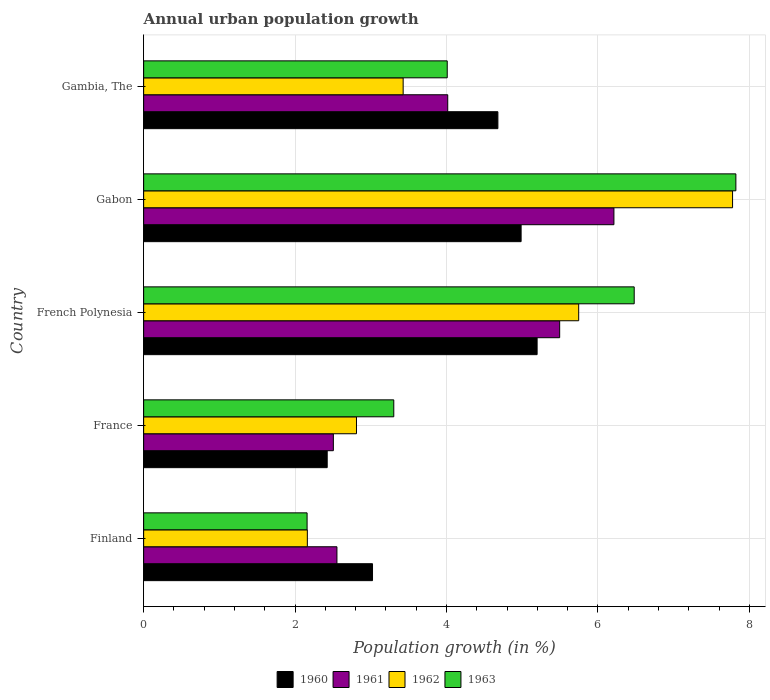Are the number of bars per tick equal to the number of legend labels?
Your response must be concise. Yes. Are the number of bars on each tick of the Y-axis equal?
Ensure brevity in your answer.  Yes. How many bars are there on the 1st tick from the top?
Your response must be concise. 4. How many bars are there on the 2nd tick from the bottom?
Your answer should be compact. 4. What is the label of the 2nd group of bars from the top?
Provide a short and direct response. Gabon. What is the percentage of urban population growth in 1963 in Gabon?
Provide a succinct answer. 7.82. Across all countries, what is the maximum percentage of urban population growth in 1963?
Offer a terse response. 7.82. Across all countries, what is the minimum percentage of urban population growth in 1962?
Ensure brevity in your answer.  2.16. In which country was the percentage of urban population growth in 1962 maximum?
Offer a very short reply. Gabon. In which country was the percentage of urban population growth in 1963 minimum?
Your answer should be compact. Finland. What is the total percentage of urban population growth in 1962 in the graph?
Offer a very short reply. 21.93. What is the difference between the percentage of urban population growth in 1961 in Finland and that in Gabon?
Offer a terse response. -3.66. What is the difference between the percentage of urban population growth in 1960 in France and the percentage of urban population growth in 1963 in Gambia, The?
Offer a terse response. -1.59. What is the average percentage of urban population growth in 1962 per country?
Your answer should be compact. 4.39. What is the difference between the percentage of urban population growth in 1961 and percentage of urban population growth in 1963 in Finland?
Your response must be concise. 0.39. In how many countries, is the percentage of urban population growth in 1963 greater than 5.6 %?
Your response must be concise. 2. What is the ratio of the percentage of urban population growth in 1963 in France to that in Gabon?
Your answer should be very brief. 0.42. What is the difference between the highest and the second highest percentage of urban population growth in 1962?
Provide a succinct answer. 2.03. What is the difference between the highest and the lowest percentage of urban population growth in 1960?
Your response must be concise. 2.77. In how many countries, is the percentage of urban population growth in 1963 greater than the average percentage of urban population growth in 1963 taken over all countries?
Offer a terse response. 2. Is it the case that in every country, the sum of the percentage of urban population growth in 1961 and percentage of urban population growth in 1962 is greater than the sum of percentage of urban population growth in 1960 and percentage of urban population growth in 1963?
Offer a very short reply. No. What does the 1st bar from the top in France represents?
Offer a terse response. 1963. What does the 3rd bar from the bottom in Gambia, The represents?
Your answer should be compact. 1962. Is it the case that in every country, the sum of the percentage of urban population growth in 1960 and percentage of urban population growth in 1961 is greater than the percentage of urban population growth in 1962?
Ensure brevity in your answer.  Yes. How many bars are there?
Make the answer very short. 20. Are all the bars in the graph horizontal?
Offer a very short reply. Yes. What is the difference between two consecutive major ticks on the X-axis?
Provide a short and direct response. 2. Are the values on the major ticks of X-axis written in scientific E-notation?
Provide a short and direct response. No. What is the title of the graph?
Provide a short and direct response. Annual urban population growth. Does "1960" appear as one of the legend labels in the graph?
Ensure brevity in your answer.  Yes. What is the label or title of the X-axis?
Give a very brief answer. Population growth (in %). What is the label or title of the Y-axis?
Ensure brevity in your answer.  Country. What is the Population growth (in %) in 1960 in Finland?
Offer a terse response. 3.02. What is the Population growth (in %) in 1961 in Finland?
Make the answer very short. 2.55. What is the Population growth (in %) in 1962 in Finland?
Offer a very short reply. 2.16. What is the Population growth (in %) of 1963 in Finland?
Provide a succinct answer. 2.16. What is the Population growth (in %) in 1960 in France?
Offer a terse response. 2.42. What is the Population growth (in %) of 1961 in France?
Your response must be concise. 2.51. What is the Population growth (in %) of 1962 in France?
Ensure brevity in your answer.  2.81. What is the Population growth (in %) in 1963 in France?
Your response must be concise. 3.3. What is the Population growth (in %) in 1960 in French Polynesia?
Offer a terse response. 5.2. What is the Population growth (in %) in 1961 in French Polynesia?
Make the answer very short. 5.5. What is the Population growth (in %) of 1962 in French Polynesia?
Provide a succinct answer. 5.75. What is the Population growth (in %) of 1963 in French Polynesia?
Your response must be concise. 6.48. What is the Population growth (in %) in 1960 in Gabon?
Your answer should be compact. 4.99. What is the Population growth (in %) of 1961 in Gabon?
Keep it short and to the point. 6.21. What is the Population growth (in %) in 1962 in Gabon?
Offer a terse response. 7.78. What is the Population growth (in %) of 1963 in Gabon?
Your response must be concise. 7.82. What is the Population growth (in %) of 1960 in Gambia, The?
Provide a short and direct response. 4.68. What is the Population growth (in %) of 1961 in Gambia, The?
Offer a terse response. 4.02. What is the Population growth (in %) of 1962 in Gambia, The?
Offer a very short reply. 3.43. What is the Population growth (in %) of 1963 in Gambia, The?
Provide a succinct answer. 4.01. Across all countries, what is the maximum Population growth (in %) of 1960?
Keep it short and to the point. 5.2. Across all countries, what is the maximum Population growth (in %) in 1961?
Your answer should be very brief. 6.21. Across all countries, what is the maximum Population growth (in %) of 1962?
Provide a succinct answer. 7.78. Across all countries, what is the maximum Population growth (in %) of 1963?
Make the answer very short. 7.82. Across all countries, what is the minimum Population growth (in %) of 1960?
Offer a terse response. 2.42. Across all countries, what is the minimum Population growth (in %) in 1961?
Keep it short and to the point. 2.51. Across all countries, what is the minimum Population growth (in %) in 1962?
Make the answer very short. 2.16. Across all countries, what is the minimum Population growth (in %) of 1963?
Offer a terse response. 2.16. What is the total Population growth (in %) in 1960 in the graph?
Provide a short and direct response. 20.31. What is the total Population growth (in %) in 1961 in the graph?
Your answer should be compact. 20.78. What is the total Population growth (in %) of 1962 in the graph?
Ensure brevity in your answer.  21.93. What is the total Population growth (in %) in 1963 in the graph?
Offer a very short reply. 23.78. What is the difference between the Population growth (in %) in 1960 in Finland and that in France?
Offer a terse response. 0.6. What is the difference between the Population growth (in %) in 1961 in Finland and that in France?
Provide a succinct answer. 0.05. What is the difference between the Population growth (in %) in 1962 in Finland and that in France?
Offer a terse response. -0.65. What is the difference between the Population growth (in %) of 1963 in Finland and that in France?
Offer a very short reply. -1.15. What is the difference between the Population growth (in %) in 1960 in Finland and that in French Polynesia?
Your answer should be very brief. -2.17. What is the difference between the Population growth (in %) of 1961 in Finland and that in French Polynesia?
Keep it short and to the point. -2.94. What is the difference between the Population growth (in %) of 1962 in Finland and that in French Polynesia?
Ensure brevity in your answer.  -3.58. What is the difference between the Population growth (in %) of 1963 in Finland and that in French Polynesia?
Provide a succinct answer. -4.32. What is the difference between the Population growth (in %) of 1960 in Finland and that in Gabon?
Ensure brevity in your answer.  -1.96. What is the difference between the Population growth (in %) in 1961 in Finland and that in Gabon?
Your answer should be very brief. -3.66. What is the difference between the Population growth (in %) in 1962 in Finland and that in Gabon?
Ensure brevity in your answer.  -5.62. What is the difference between the Population growth (in %) of 1963 in Finland and that in Gabon?
Give a very brief answer. -5.66. What is the difference between the Population growth (in %) of 1960 in Finland and that in Gambia, The?
Provide a succinct answer. -1.66. What is the difference between the Population growth (in %) in 1961 in Finland and that in Gambia, The?
Your answer should be very brief. -1.46. What is the difference between the Population growth (in %) of 1962 in Finland and that in Gambia, The?
Give a very brief answer. -1.27. What is the difference between the Population growth (in %) of 1963 in Finland and that in Gambia, The?
Give a very brief answer. -1.85. What is the difference between the Population growth (in %) in 1960 in France and that in French Polynesia?
Provide a short and direct response. -2.77. What is the difference between the Population growth (in %) in 1961 in France and that in French Polynesia?
Your answer should be very brief. -2.99. What is the difference between the Population growth (in %) in 1962 in France and that in French Polynesia?
Make the answer very short. -2.94. What is the difference between the Population growth (in %) in 1963 in France and that in French Polynesia?
Ensure brevity in your answer.  -3.18. What is the difference between the Population growth (in %) in 1960 in France and that in Gabon?
Ensure brevity in your answer.  -2.56. What is the difference between the Population growth (in %) in 1961 in France and that in Gabon?
Give a very brief answer. -3.71. What is the difference between the Population growth (in %) of 1962 in France and that in Gabon?
Provide a short and direct response. -4.97. What is the difference between the Population growth (in %) of 1963 in France and that in Gabon?
Make the answer very short. -4.52. What is the difference between the Population growth (in %) of 1960 in France and that in Gambia, The?
Your response must be concise. -2.25. What is the difference between the Population growth (in %) in 1961 in France and that in Gambia, The?
Your response must be concise. -1.51. What is the difference between the Population growth (in %) in 1962 in France and that in Gambia, The?
Your answer should be very brief. -0.62. What is the difference between the Population growth (in %) of 1963 in France and that in Gambia, The?
Your answer should be compact. -0.71. What is the difference between the Population growth (in %) of 1960 in French Polynesia and that in Gabon?
Your answer should be very brief. 0.21. What is the difference between the Population growth (in %) of 1961 in French Polynesia and that in Gabon?
Provide a succinct answer. -0.72. What is the difference between the Population growth (in %) of 1962 in French Polynesia and that in Gabon?
Your response must be concise. -2.03. What is the difference between the Population growth (in %) of 1963 in French Polynesia and that in Gabon?
Provide a short and direct response. -1.34. What is the difference between the Population growth (in %) of 1960 in French Polynesia and that in Gambia, The?
Provide a short and direct response. 0.52. What is the difference between the Population growth (in %) of 1961 in French Polynesia and that in Gambia, The?
Give a very brief answer. 1.48. What is the difference between the Population growth (in %) in 1962 in French Polynesia and that in Gambia, The?
Offer a terse response. 2.32. What is the difference between the Population growth (in %) in 1963 in French Polynesia and that in Gambia, The?
Offer a terse response. 2.47. What is the difference between the Population growth (in %) of 1960 in Gabon and that in Gambia, The?
Offer a very short reply. 0.31. What is the difference between the Population growth (in %) of 1961 in Gabon and that in Gambia, The?
Provide a short and direct response. 2.2. What is the difference between the Population growth (in %) in 1962 in Gabon and that in Gambia, The?
Offer a terse response. 4.35. What is the difference between the Population growth (in %) in 1963 in Gabon and that in Gambia, The?
Your response must be concise. 3.81. What is the difference between the Population growth (in %) of 1960 in Finland and the Population growth (in %) of 1961 in France?
Provide a short and direct response. 0.52. What is the difference between the Population growth (in %) of 1960 in Finland and the Population growth (in %) of 1962 in France?
Keep it short and to the point. 0.21. What is the difference between the Population growth (in %) in 1960 in Finland and the Population growth (in %) in 1963 in France?
Provide a succinct answer. -0.28. What is the difference between the Population growth (in %) in 1961 in Finland and the Population growth (in %) in 1962 in France?
Your answer should be compact. -0.26. What is the difference between the Population growth (in %) of 1961 in Finland and the Population growth (in %) of 1963 in France?
Offer a terse response. -0.75. What is the difference between the Population growth (in %) of 1962 in Finland and the Population growth (in %) of 1963 in France?
Keep it short and to the point. -1.14. What is the difference between the Population growth (in %) of 1960 in Finland and the Population growth (in %) of 1961 in French Polynesia?
Offer a terse response. -2.47. What is the difference between the Population growth (in %) of 1960 in Finland and the Population growth (in %) of 1962 in French Polynesia?
Your response must be concise. -2.72. What is the difference between the Population growth (in %) in 1960 in Finland and the Population growth (in %) in 1963 in French Polynesia?
Provide a succinct answer. -3.46. What is the difference between the Population growth (in %) of 1961 in Finland and the Population growth (in %) of 1962 in French Polynesia?
Ensure brevity in your answer.  -3.19. What is the difference between the Population growth (in %) in 1961 in Finland and the Population growth (in %) in 1963 in French Polynesia?
Give a very brief answer. -3.93. What is the difference between the Population growth (in %) of 1962 in Finland and the Population growth (in %) of 1963 in French Polynesia?
Offer a very short reply. -4.32. What is the difference between the Population growth (in %) in 1960 in Finland and the Population growth (in %) in 1961 in Gabon?
Give a very brief answer. -3.19. What is the difference between the Population growth (in %) of 1960 in Finland and the Population growth (in %) of 1962 in Gabon?
Offer a terse response. -4.76. What is the difference between the Population growth (in %) in 1960 in Finland and the Population growth (in %) in 1963 in Gabon?
Give a very brief answer. -4.8. What is the difference between the Population growth (in %) in 1961 in Finland and the Population growth (in %) in 1962 in Gabon?
Your answer should be compact. -5.23. What is the difference between the Population growth (in %) in 1961 in Finland and the Population growth (in %) in 1963 in Gabon?
Give a very brief answer. -5.27. What is the difference between the Population growth (in %) in 1962 in Finland and the Population growth (in %) in 1963 in Gabon?
Make the answer very short. -5.66. What is the difference between the Population growth (in %) in 1960 in Finland and the Population growth (in %) in 1961 in Gambia, The?
Provide a succinct answer. -0.99. What is the difference between the Population growth (in %) in 1960 in Finland and the Population growth (in %) in 1962 in Gambia, The?
Offer a terse response. -0.4. What is the difference between the Population growth (in %) in 1960 in Finland and the Population growth (in %) in 1963 in Gambia, The?
Give a very brief answer. -0.99. What is the difference between the Population growth (in %) of 1961 in Finland and the Population growth (in %) of 1962 in Gambia, The?
Ensure brevity in your answer.  -0.87. What is the difference between the Population growth (in %) of 1961 in Finland and the Population growth (in %) of 1963 in Gambia, The?
Make the answer very short. -1.46. What is the difference between the Population growth (in %) in 1962 in Finland and the Population growth (in %) in 1963 in Gambia, The?
Ensure brevity in your answer.  -1.85. What is the difference between the Population growth (in %) of 1960 in France and the Population growth (in %) of 1961 in French Polynesia?
Offer a terse response. -3.07. What is the difference between the Population growth (in %) of 1960 in France and the Population growth (in %) of 1962 in French Polynesia?
Give a very brief answer. -3.32. What is the difference between the Population growth (in %) in 1960 in France and the Population growth (in %) in 1963 in French Polynesia?
Your answer should be very brief. -4.06. What is the difference between the Population growth (in %) in 1961 in France and the Population growth (in %) in 1962 in French Polynesia?
Give a very brief answer. -3.24. What is the difference between the Population growth (in %) in 1961 in France and the Population growth (in %) in 1963 in French Polynesia?
Provide a short and direct response. -3.97. What is the difference between the Population growth (in %) in 1962 in France and the Population growth (in %) in 1963 in French Polynesia?
Ensure brevity in your answer.  -3.67. What is the difference between the Population growth (in %) in 1960 in France and the Population growth (in %) in 1961 in Gabon?
Make the answer very short. -3.79. What is the difference between the Population growth (in %) of 1960 in France and the Population growth (in %) of 1962 in Gabon?
Your response must be concise. -5.35. What is the difference between the Population growth (in %) of 1960 in France and the Population growth (in %) of 1963 in Gabon?
Your answer should be compact. -5.4. What is the difference between the Population growth (in %) of 1961 in France and the Population growth (in %) of 1962 in Gabon?
Give a very brief answer. -5.27. What is the difference between the Population growth (in %) in 1961 in France and the Population growth (in %) in 1963 in Gabon?
Your response must be concise. -5.32. What is the difference between the Population growth (in %) in 1962 in France and the Population growth (in %) in 1963 in Gabon?
Keep it short and to the point. -5.01. What is the difference between the Population growth (in %) of 1960 in France and the Population growth (in %) of 1961 in Gambia, The?
Offer a terse response. -1.59. What is the difference between the Population growth (in %) in 1960 in France and the Population growth (in %) in 1962 in Gambia, The?
Give a very brief answer. -1. What is the difference between the Population growth (in %) of 1960 in France and the Population growth (in %) of 1963 in Gambia, The?
Make the answer very short. -1.59. What is the difference between the Population growth (in %) in 1961 in France and the Population growth (in %) in 1962 in Gambia, The?
Offer a very short reply. -0.92. What is the difference between the Population growth (in %) in 1961 in France and the Population growth (in %) in 1963 in Gambia, The?
Provide a short and direct response. -1.5. What is the difference between the Population growth (in %) in 1962 in France and the Population growth (in %) in 1963 in Gambia, The?
Offer a terse response. -1.2. What is the difference between the Population growth (in %) in 1960 in French Polynesia and the Population growth (in %) in 1961 in Gabon?
Your answer should be compact. -1.01. What is the difference between the Population growth (in %) in 1960 in French Polynesia and the Population growth (in %) in 1962 in Gabon?
Offer a very short reply. -2.58. What is the difference between the Population growth (in %) in 1960 in French Polynesia and the Population growth (in %) in 1963 in Gabon?
Give a very brief answer. -2.63. What is the difference between the Population growth (in %) in 1961 in French Polynesia and the Population growth (in %) in 1962 in Gabon?
Offer a very short reply. -2.28. What is the difference between the Population growth (in %) in 1961 in French Polynesia and the Population growth (in %) in 1963 in Gabon?
Your answer should be very brief. -2.33. What is the difference between the Population growth (in %) of 1962 in French Polynesia and the Population growth (in %) of 1963 in Gabon?
Offer a very short reply. -2.08. What is the difference between the Population growth (in %) of 1960 in French Polynesia and the Population growth (in %) of 1961 in Gambia, The?
Give a very brief answer. 1.18. What is the difference between the Population growth (in %) in 1960 in French Polynesia and the Population growth (in %) in 1962 in Gambia, The?
Keep it short and to the point. 1.77. What is the difference between the Population growth (in %) of 1960 in French Polynesia and the Population growth (in %) of 1963 in Gambia, The?
Your answer should be compact. 1.19. What is the difference between the Population growth (in %) of 1961 in French Polynesia and the Population growth (in %) of 1962 in Gambia, The?
Make the answer very short. 2.07. What is the difference between the Population growth (in %) in 1961 in French Polynesia and the Population growth (in %) in 1963 in Gambia, The?
Provide a succinct answer. 1.49. What is the difference between the Population growth (in %) in 1962 in French Polynesia and the Population growth (in %) in 1963 in Gambia, The?
Make the answer very short. 1.74. What is the difference between the Population growth (in %) in 1960 in Gabon and the Population growth (in %) in 1961 in Gambia, The?
Your response must be concise. 0.97. What is the difference between the Population growth (in %) of 1960 in Gabon and the Population growth (in %) of 1962 in Gambia, The?
Your answer should be compact. 1.56. What is the difference between the Population growth (in %) of 1960 in Gabon and the Population growth (in %) of 1963 in Gambia, The?
Your response must be concise. 0.98. What is the difference between the Population growth (in %) in 1961 in Gabon and the Population growth (in %) in 1962 in Gambia, The?
Offer a very short reply. 2.78. What is the difference between the Population growth (in %) of 1961 in Gabon and the Population growth (in %) of 1963 in Gambia, The?
Provide a short and direct response. 2.2. What is the difference between the Population growth (in %) of 1962 in Gabon and the Population growth (in %) of 1963 in Gambia, The?
Provide a short and direct response. 3.77. What is the average Population growth (in %) in 1960 per country?
Keep it short and to the point. 4.06. What is the average Population growth (in %) of 1961 per country?
Give a very brief answer. 4.16. What is the average Population growth (in %) in 1962 per country?
Keep it short and to the point. 4.39. What is the average Population growth (in %) of 1963 per country?
Offer a terse response. 4.76. What is the difference between the Population growth (in %) in 1960 and Population growth (in %) in 1961 in Finland?
Make the answer very short. 0.47. What is the difference between the Population growth (in %) in 1960 and Population growth (in %) in 1962 in Finland?
Your answer should be very brief. 0.86. What is the difference between the Population growth (in %) in 1960 and Population growth (in %) in 1963 in Finland?
Provide a short and direct response. 0.86. What is the difference between the Population growth (in %) in 1961 and Population growth (in %) in 1962 in Finland?
Offer a very short reply. 0.39. What is the difference between the Population growth (in %) of 1961 and Population growth (in %) of 1963 in Finland?
Your response must be concise. 0.39. What is the difference between the Population growth (in %) in 1962 and Population growth (in %) in 1963 in Finland?
Give a very brief answer. 0. What is the difference between the Population growth (in %) in 1960 and Population growth (in %) in 1961 in France?
Ensure brevity in your answer.  -0.08. What is the difference between the Population growth (in %) in 1960 and Population growth (in %) in 1962 in France?
Keep it short and to the point. -0.39. What is the difference between the Population growth (in %) of 1960 and Population growth (in %) of 1963 in France?
Offer a very short reply. -0.88. What is the difference between the Population growth (in %) in 1961 and Population growth (in %) in 1962 in France?
Your answer should be compact. -0.31. What is the difference between the Population growth (in %) of 1961 and Population growth (in %) of 1963 in France?
Your answer should be very brief. -0.8. What is the difference between the Population growth (in %) in 1962 and Population growth (in %) in 1963 in France?
Give a very brief answer. -0.49. What is the difference between the Population growth (in %) of 1960 and Population growth (in %) of 1961 in French Polynesia?
Give a very brief answer. -0.3. What is the difference between the Population growth (in %) in 1960 and Population growth (in %) in 1962 in French Polynesia?
Your response must be concise. -0.55. What is the difference between the Population growth (in %) of 1960 and Population growth (in %) of 1963 in French Polynesia?
Keep it short and to the point. -1.28. What is the difference between the Population growth (in %) of 1961 and Population growth (in %) of 1962 in French Polynesia?
Provide a short and direct response. -0.25. What is the difference between the Population growth (in %) in 1961 and Population growth (in %) in 1963 in French Polynesia?
Your answer should be compact. -0.98. What is the difference between the Population growth (in %) in 1962 and Population growth (in %) in 1963 in French Polynesia?
Offer a very short reply. -0.73. What is the difference between the Population growth (in %) of 1960 and Population growth (in %) of 1961 in Gabon?
Offer a very short reply. -1.23. What is the difference between the Population growth (in %) in 1960 and Population growth (in %) in 1962 in Gabon?
Make the answer very short. -2.79. What is the difference between the Population growth (in %) in 1960 and Population growth (in %) in 1963 in Gabon?
Your answer should be compact. -2.84. What is the difference between the Population growth (in %) in 1961 and Population growth (in %) in 1962 in Gabon?
Ensure brevity in your answer.  -1.57. What is the difference between the Population growth (in %) of 1961 and Population growth (in %) of 1963 in Gabon?
Keep it short and to the point. -1.61. What is the difference between the Population growth (in %) in 1962 and Population growth (in %) in 1963 in Gabon?
Your response must be concise. -0.04. What is the difference between the Population growth (in %) of 1960 and Population growth (in %) of 1961 in Gambia, The?
Provide a succinct answer. 0.66. What is the difference between the Population growth (in %) of 1960 and Population growth (in %) of 1962 in Gambia, The?
Your answer should be very brief. 1.25. What is the difference between the Population growth (in %) of 1960 and Population growth (in %) of 1963 in Gambia, The?
Your response must be concise. 0.67. What is the difference between the Population growth (in %) in 1961 and Population growth (in %) in 1962 in Gambia, The?
Your response must be concise. 0.59. What is the difference between the Population growth (in %) in 1961 and Population growth (in %) in 1963 in Gambia, The?
Your answer should be compact. 0.01. What is the difference between the Population growth (in %) in 1962 and Population growth (in %) in 1963 in Gambia, The?
Offer a very short reply. -0.58. What is the ratio of the Population growth (in %) in 1960 in Finland to that in France?
Offer a very short reply. 1.25. What is the ratio of the Population growth (in %) of 1961 in Finland to that in France?
Provide a short and direct response. 1.02. What is the ratio of the Population growth (in %) of 1962 in Finland to that in France?
Provide a succinct answer. 0.77. What is the ratio of the Population growth (in %) in 1963 in Finland to that in France?
Your response must be concise. 0.65. What is the ratio of the Population growth (in %) of 1960 in Finland to that in French Polynesia?
Offer a terse response. 0.58. What is the ratio of the Population growth (in %) of 1961 in Finland to that in French Polynesia?
Give a very brief answer. 0.46. What is the ratio of the Population growth (in %) of 1962 in Finland to that in French Polynesia?
Give a very brief answer. 0.38. What is the ratio of the Population growth (in %) in 1963 in Finland to that in French Polynesia?
Offer a terse response. 0.33. What is the ratio of the Population growth (in %) of 1960 in Finland to that in Gabon?
Your response must be concise. 0.61. What is the ratio of the Population growth (in %) in 1961 in Finland to that in Gabon?
Your answer should be compact. 0.41. What is the ratio of the Population growth (in %) of 1962 in Finland to that in Gabon?
Offer a very short reply. 0.28. What is the ratio of the Population growth (in %) in 1963 in Finland to that in Gabon?
Provide a succinct answer. 0.28. What is the ratio of the Population growth (in %) of 1960 in Finland to that in Gambia, The?
Offer a terse response. 0.65. What is the ratio of the Population growth (in %) in 1961 in Finland to that in Gambia, The?
Give a very brief answer. 0.64. What is the ratio of the Population growth (in %) in 1962 in Finland to that in Gambia, The?
Your answer should be very brief. 0.63. What is the ratio of the Population growth (in %) in 1963 in Finland to that in Gambia, The?
Your answer should be compact. 0.54. What is the ratio of the Population growth (in %) of 1960 in France to that in French Polynesia?
Provide a succinct answer. 0.47. What is the ratio of the Population growth (in %) of 1961 in France to that in French Polynesia?
Give a very brief answer. 0.46. What is the ratio of the Population growth (in %) of 1962 in France to that in French Polynesia?
Your response must be concise. 0.49. What is the ratio of the Population growth (in %) of 1963 in France to that in French Polynesia?
Provide a short and direct response. 0.51. What is the ratio of the Population growth (in %) of 1960 in France to that in Gabon?
Your answer should be very brief. 0.49. What is the ratio of the Population growth (in %) of 1961 in France to that in Gabon?
Your answer should be compact. 0.4. What is the ratio of the Population growth (in %) in 1962 in France to that in Gabon?
Make the answer very short. 0.36. What is the ratio of the Population growth (in %) in 1963 in France to that in Gabon?
Your response must be concise. 0.42. What is the ratio of the Population growth (in %) of 1960 in France to that in Gambia, The?
Offer a terse response. 0.52. What is the ratio of the Population growth (in %) of 1961 in France to that in Gambia, The?
Give a very brief answer. 0.62. What is the ratio of the Population growth (in %) in 1962 in France to that in Gambia, The?
Make the answer very short. 0.82. What is the ratio of the Population growth (in %) in 1963 in France to that in Gambia, The?
Your answer should be very brief. 0.82. What is the ratio of the Population growth (in %) of 1960 in French Polynesia to that in Gabon?
Offer a terse response. 1.04. What is the ratio of the Population growth (in %) of 1961 in French Polynesia to that in Gabon?
Your response must be concise. 0.88. What is the ratio of the Population growth (in %) of 1962 in French Polynesia to that in Gabon?
Keep it short and to the point. 0.74. What is the ratio of the Population growth (in %) in 1963 in French Polynesia to that in Gabon?
Keep it short and to the point. 0.83. What is the ratio of the Population growth (in %) of 1960 in French Polynesia to that in Gambia, The?
Your response must be concise. 1.11. What is the ratio of the Population growth (in %) in 1961 in French Polynesia to that in Gambia, The?
Offer a very short reply. 1.37. What is the ratio of the Population growth (in %) of 1962 in French Polynesia to that in Gambia, The?
Ensure brevity in your answer.  1.68. What is the ratio of the Population growth (in %) in 1963 in French Polynesia to that in Gambia, The?
Provide a succinct answer. 1.62. What is the ratio of the Population growth (in %) of 1960 in Gabon to that in Gambia, The?
Give a very brief answer. 1.07. What is the ratio of the Population growth (in %) of 1961 in Gabon to that in Gambia, The?
Provide a short and direct response. 1.55. What is the ratio of the Population growth (in %) in 1962 in Gabon to that in Gambia, The?
Offer a very short reply. 2.27. What is the ratio of the Population growth (in %) in 1963 in Gabon to that in Gambia, The?
Offer a very short reply. 1.95. What is the difference between the highest and the second highest Population growth (in %) in 1960?
Your answer should be very brief. 0.21. What is the difference between the highest and the second highest Population growth (in %) of 1961?
Keep it short and to the point. 0.72. What is the difference between the highest and the second highest Population growth (in %) of 1962?
Give a very brief answer. 2.03. What is the difference between the highest and the second highest Population growth (in %) of 1963?
Make the answer very short. 1.34. What is the difference between the highest and the lowest Population growth (in %) in 1960?
Offer a very short reply. 2.77. What is the difference between the highest and the lowest Population growth (in %) of 1961?
Offer a terse response. 3.71. What is the difference between the highest and the lowest Population growth (in %) in 1962?
Offer a terse response. 5.62. What is the difference between the highest and the lowest Population growth (in %) in 1963?
Your answer should be very brief. 5.66. 